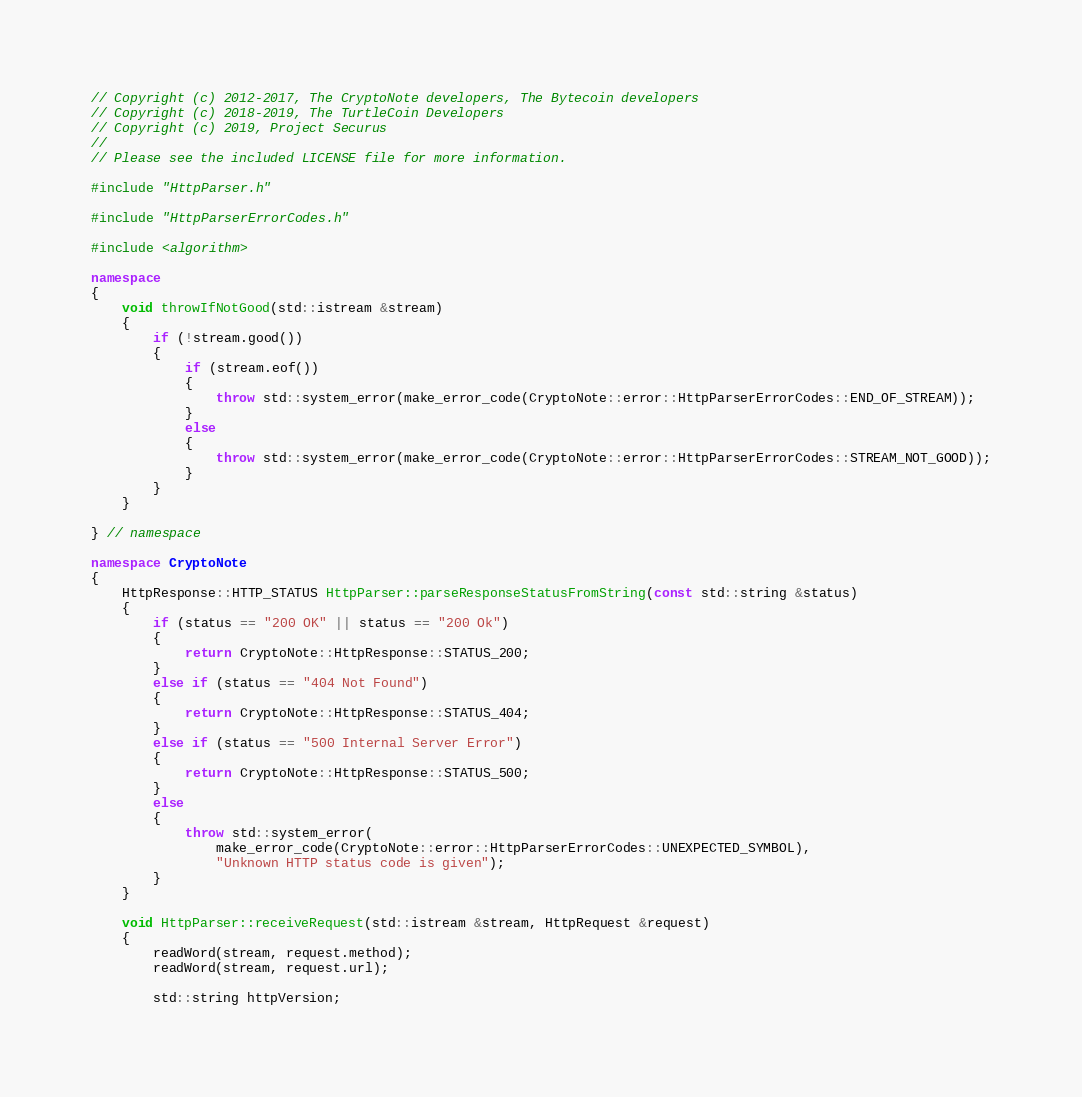Convert code to text. <code><loc_0><loc_0><loc_500><loc_500><_C++_>// Copyright (c) 2012-2017, The CryptoNote developers, The Bytecoin developers
// Copyright (c) 2018-2019, The TurtleCoin Developers
// Copyright (c) 2019, Project Securus
//
// Please see the included LICENSE file for more information.

#include "HttpParser.h"

#include "HttpParserErrorCodes.h"

#include <algorithm>

namespace
{
    void throwIfNotGood(std::istream &stream)
    {
        if (!stream.good())
        {
            if (stream.eof())
            {
                throw std::system_error(make_error_code(CryptoNote::error::HttpParserErrorCodes::END_OF_STREAM));
            }
            else
            {
                throw std::system_error(make_error_code(CryptoNote::error::HttpParserErrorCodes::STREAM_NOT_GOOD));
            }
        }
    }

} // namespace

namespace CryptoNote
{
    HttpResponse::HTTP_STATUS HttpParser::parseResponseStatusFromString(const std::string &status)
    {
        if (status == "200 OK" || status == "200 Ok")
        {
            return CryptoNote::HttpResponse::STATUS_200;
        }
        else if (status == "404 Not Found")
        {
            return CryptoNote::HttpResponse::STATUS_404;
        }
        else if (status == "500 Internal Server Error")
        {
            return CryptoNote::HttpResponse::STATUS_500;
        }
        else
        {
            throw std::system_error(
                make_error_code(CryptoNote::error::HttpParserErrorCodes::UNEXPECTED_SYMBOL),
                "Unknown HTTP status code is given");
        }
    }

    void HttpParser::receiveRequest(std::istream &stream, HttpRequest &request)
    {
        readWord(stream, request.method);
        readWord(stream, request.url);

        std::string httpVersion;</code> 